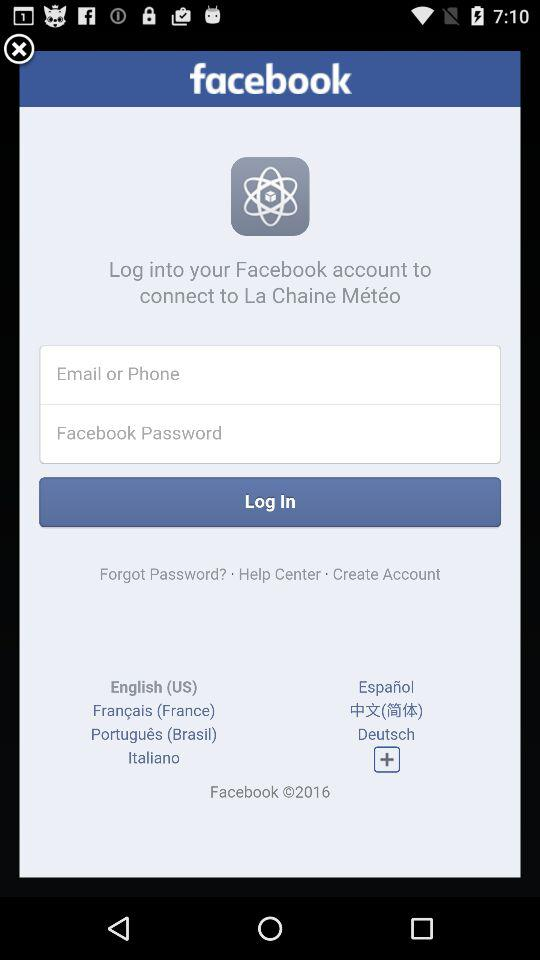How many languages are available for selection?
Answer the question using a single word or phrase. 7 